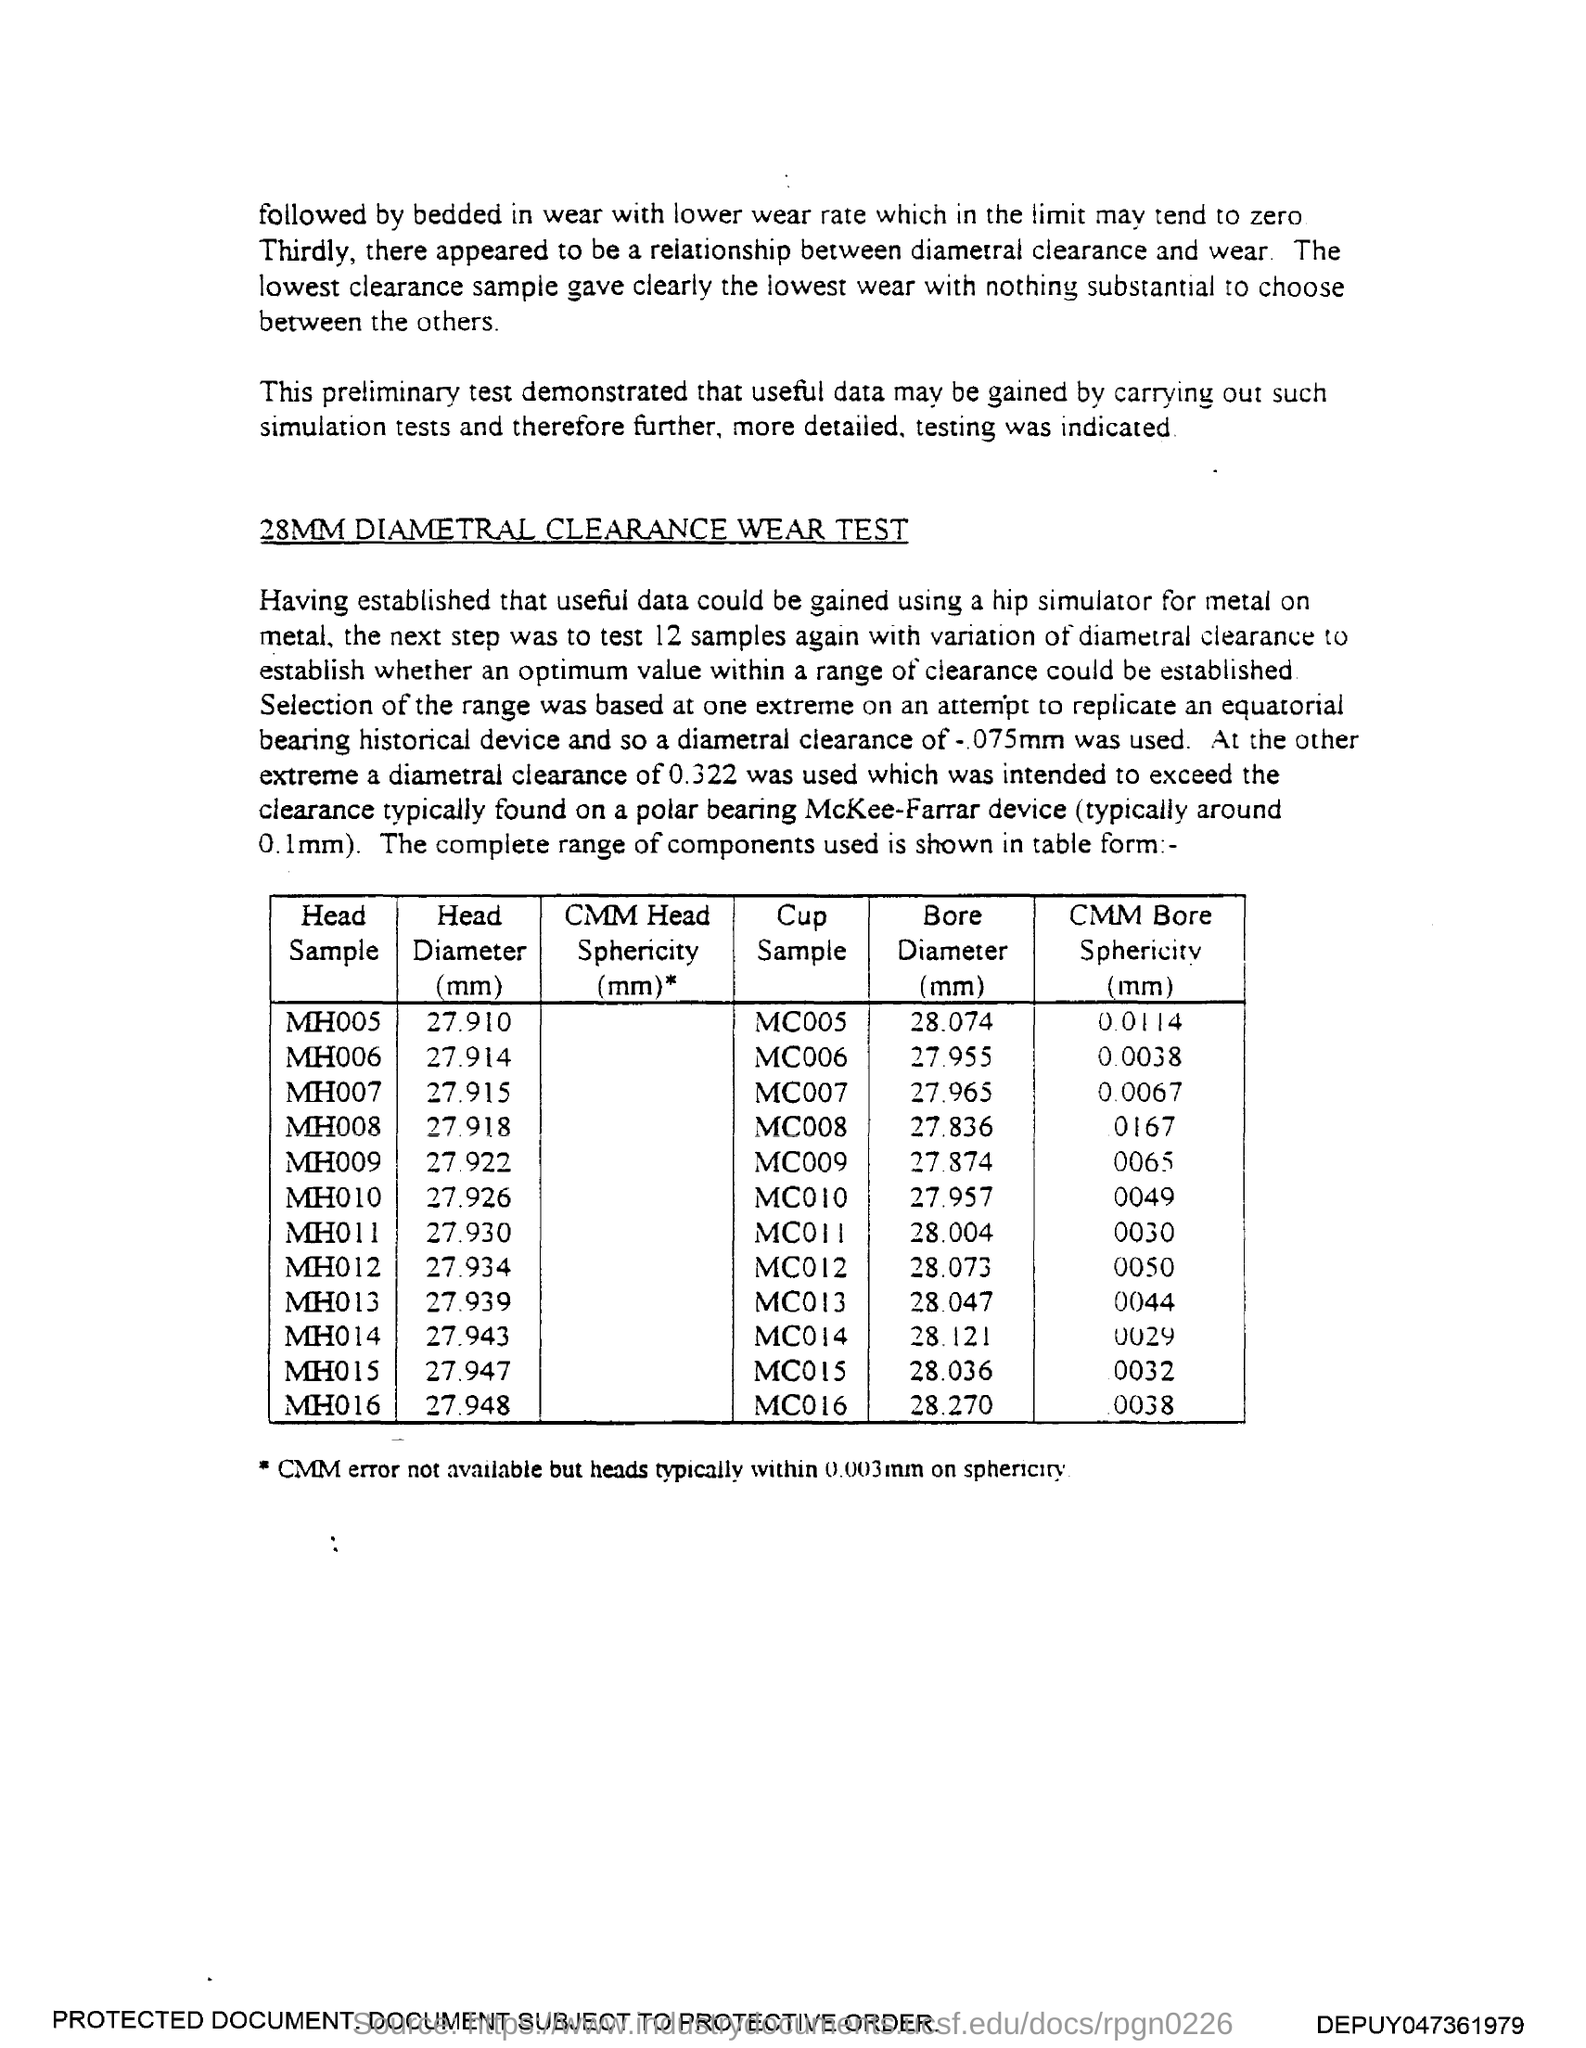What is the Head Diameter (mm) for Head Sample MH005?
Provide a succinct answer. 27.910. What is the Head Diameter (mm) for Head Sample MH006?
Ensure brevity in your answer.  27.914. What is the Head Diameter (mm) for Head Sample MH007?
Offer a terse response. 27.915. What is the Head Diameter (mm) for Head Sample MH008?
Give a very brief answer. 27.918. What is the Head Diameter (mm) for Head Sample MH009?
Your answer should be very brief. 27.922. What is the Head Diameter (mm) for Head Sample MH010?
Make the answer very short. 27.926. What is the Head Diameter (mm) for Head Sample MH011?
Your answer should be very brief. 27.930. What is the Head Diameter (mm) for Head Sample MH012?
Keep it short and to the point. 27.934. What is the Head Diameter (mm) for Head Sample MH013?
Keep it short and to the point. 27.939. What is the Head Diameter (mm) for Head Sample MH014?
Provide a succinct answer. 27.943. 